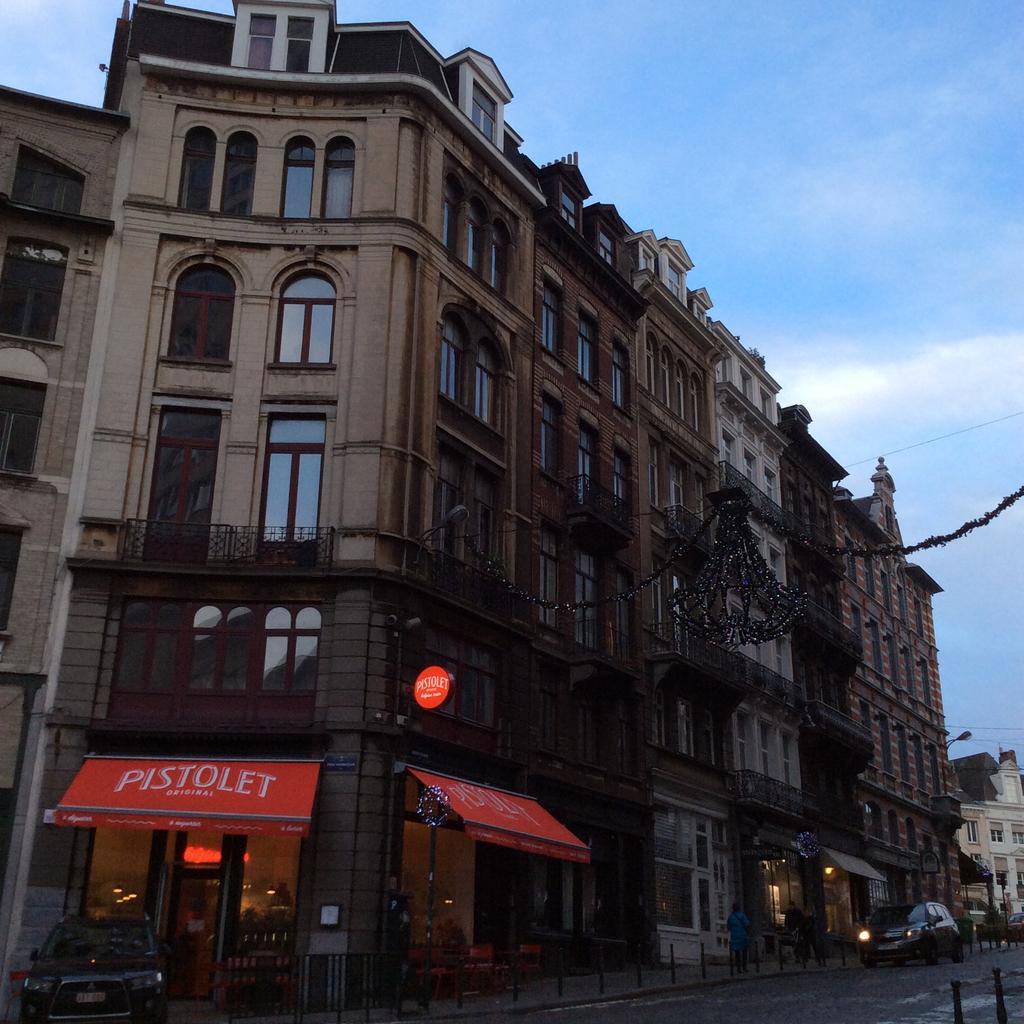Could you give a brief overview of what you see in this image? In this image we can see a few buildings, there are some windows, shops, poles, people, grille, boards with some text and a vehicle on the road, in the background we can see the sky with clouds. 